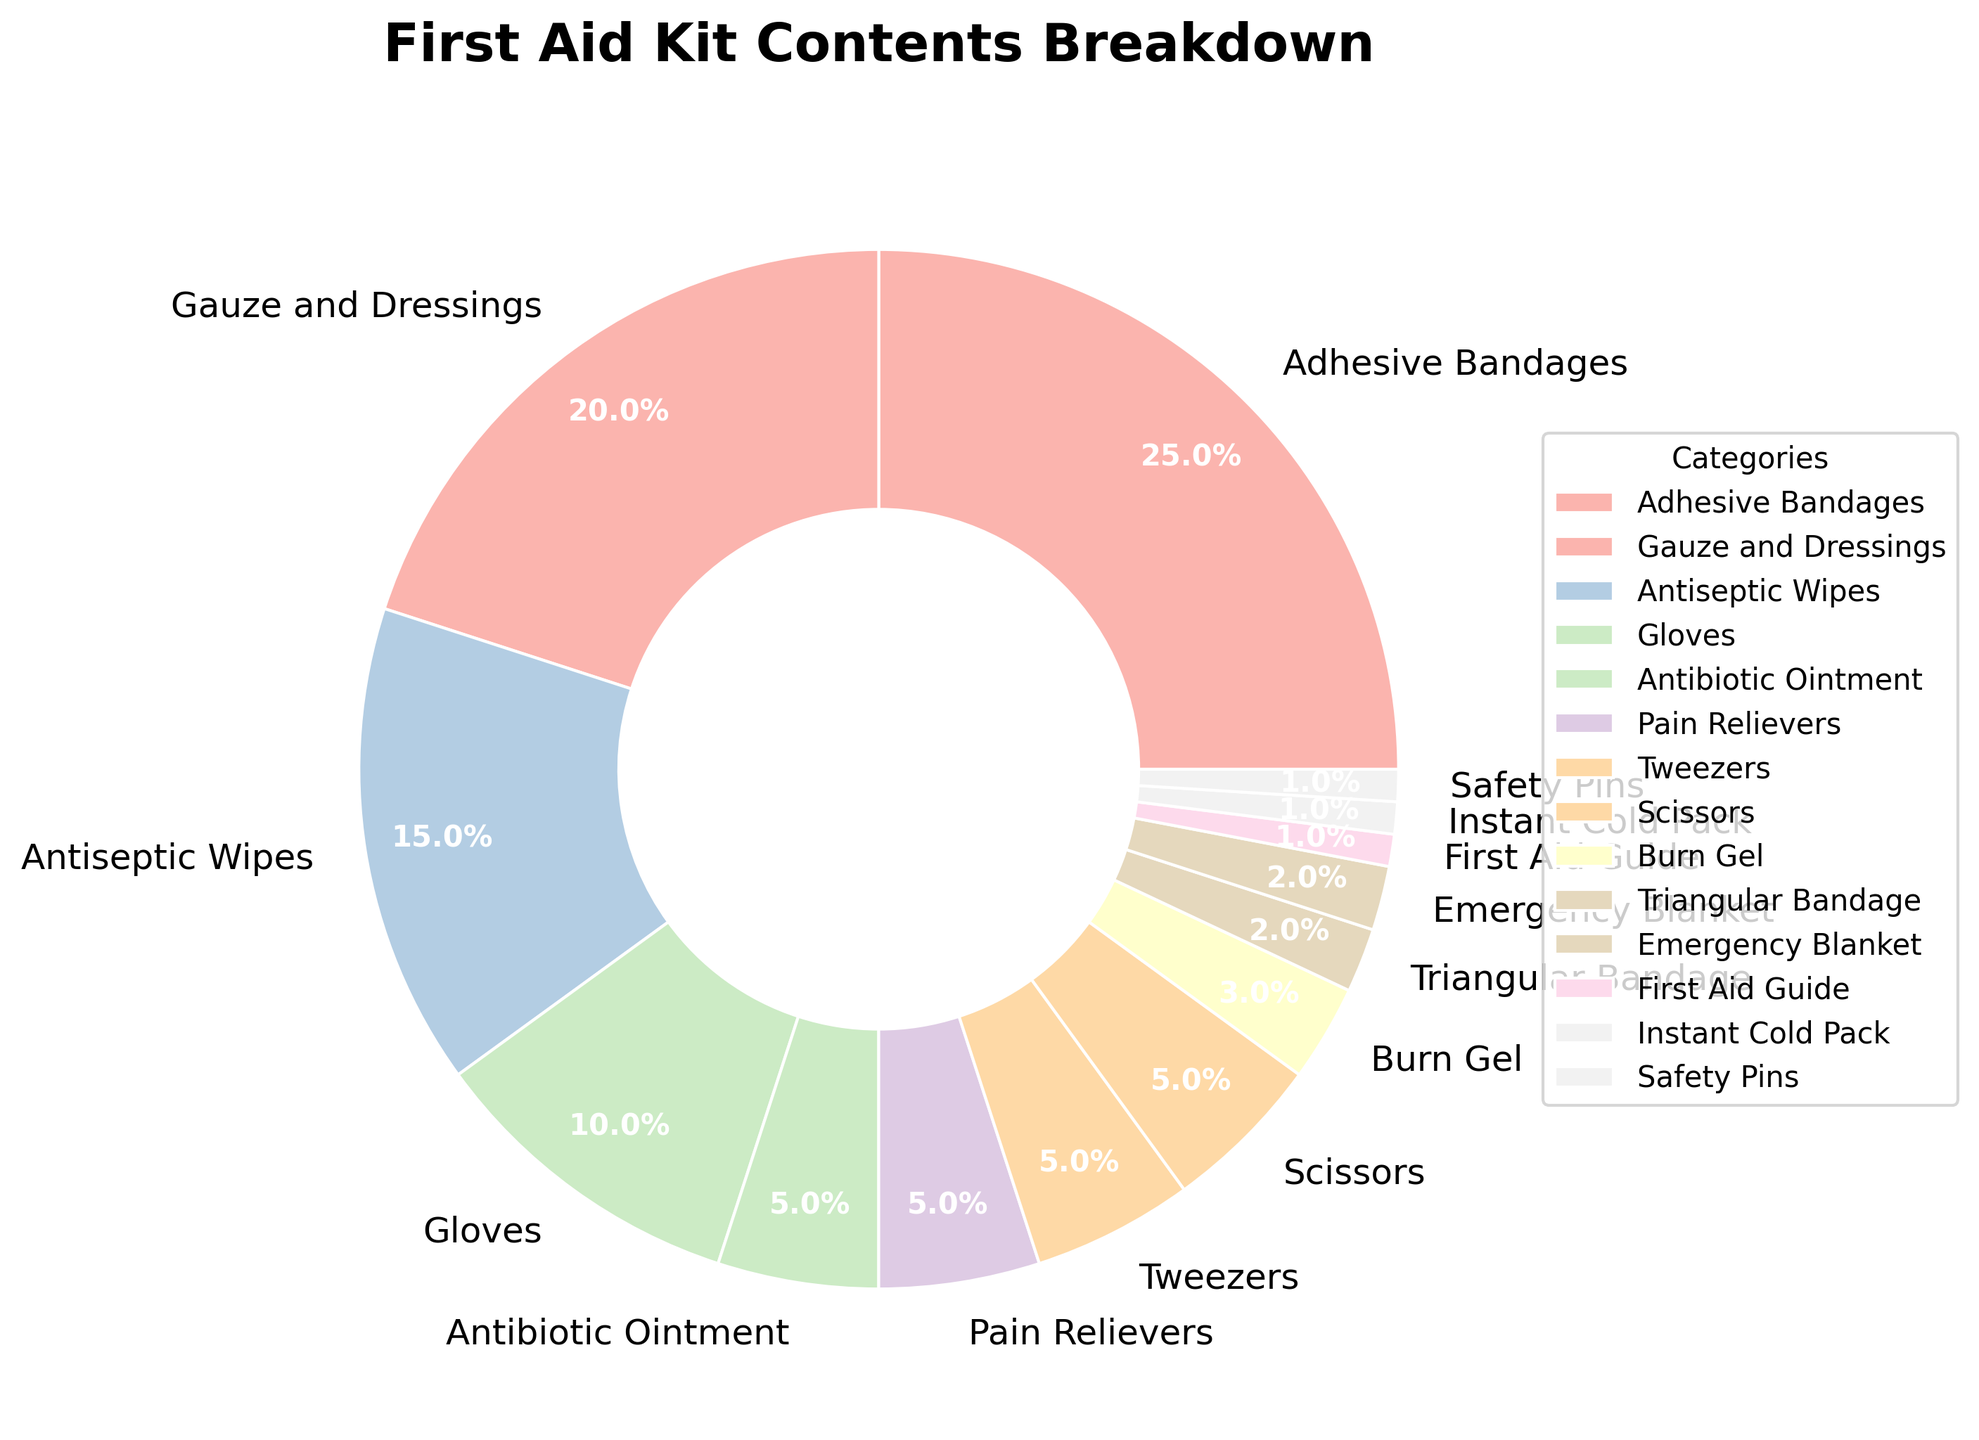What percentage of the first aid kit is made up of Adhesive Bandages and Gauze and Dressings combined? Adhesive Bandages take up 25% and Gauze and Dressings take up 20%. Adding these together gives 25% + 20% = 45%.
Answer: 45% Which category takes up a larger percentage of the kit: Antiseptic Wipes or Gloves? Antiseptic Wipes take up 15% of the kit, while Gloves take up 10%. Since 15% is greater than 10%, Antiseptic Wipes take up a larger percentage than Gloves.
Answer: Antiseptic Wipes What is the combined percentage of the less commonly included items (those with 5% or less)? The items with 5% or less are Scissors (5%), Tweezers (5%), Pain Relievers (5%), Antibiotic Ointment (5%), Burn Gel (3%), Emergency Blanket (2%), Triangular Bandage (2%), Safety Pins (1%), Instant Cold Pack (1%), and First Aid Guide (1%). Adding these percentages gives 5% + 5% + 5% + 5% + 3% + 2% + 2% + 1% + 1% + 1% = 30%.
Answer: 30% Are there more categories that take up 5% of the kit or those that take up less than 5%? Categories taking up 5% are Scissors, Tweezers, Pain Relievers, and Antibiotic Ointment, totaling 4 categories. Categories taking up less than 5% are Burn Gel, Emergency Blanket, Triangular Bandage, Safety Pins, Instant Cold Pack, and First Aid Guide, totaling 6 categories. Since 6 is greater than 4, there are more categories that take up less than 5%.
Answer: Less than 5% What proportion of the first aid kit is made up of the least common items (those with 2% or less)? The categories with 2% or less are Emergency Blanket (2%), Triangular Bandage (2%), Safety Pins (1%), Instant Cold Pack (1%), and First Aid Guide (1%). Adding these together gives 2% + 2% + 1% + 1% + 1% = 7%.
Answer: 7% Which category, if its percentage were doubled, would contribute 10% to the first aid kit? Scissors, Tweezers, Pain Relievers, and Antibiotic Ointment each contribute 5% to the kit. Doubling 5% would result in 10%.
Answer: Scissors/Tweezers/Pain Relievers/Antibiotic Ointment Which two categories have the smallest percentage in the first aid kit? Safety Pins, Instant Cold Pack, and First Aid Guide each occupy 1% of the kit. However, since the question asks for two, we would list any of the two of these three.
Answer: Safety Pins and Instant Cold Pack (or Safety Pins and First Aid Guide, or Instant Cold Pack and First Aid Guide) How much more space does the category with the largest percentage take up compared to the category with the smallest percentage? The category with the largest percentage is Adhesive Bandages at 25%, and the categories with the smallest percentage are Safety Pins, Instant Cold Pack, and First Aid Guide, each at 1%. The difference is 25% - 1% = 24%.
Answer: 24% 